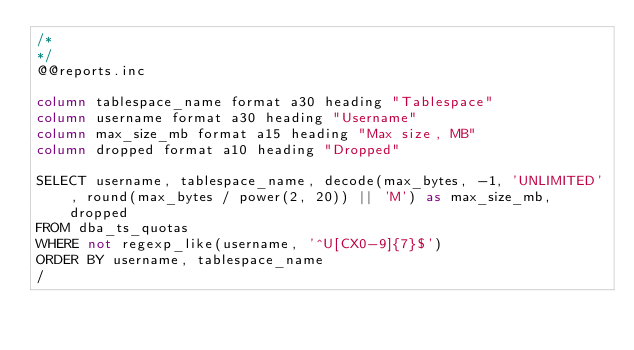Convert code to text. <code><loc_0><loc_0><loc_500><loc_500><_SQL_>/*
*/
@@reports.inc

column tablespace_name format a30 heading "Tablespace"
column username format a30 heading "Username"
column max_size_mb format a15 heading "Max size, MB"
column dropped format a10 heading "Dropped"

SELECT username, tablespace_name, decode(max_bytes, -1, 'UNLIMITED', round(max_bytes / power(2, 20)) || 'M') as max_size_mb, dropped
FROM dba_ts_quotas
WHERE not regexp_like(username, '^U[CX0-9]{7}$')
ORDER BY username, tablespace_name
/
</code> 